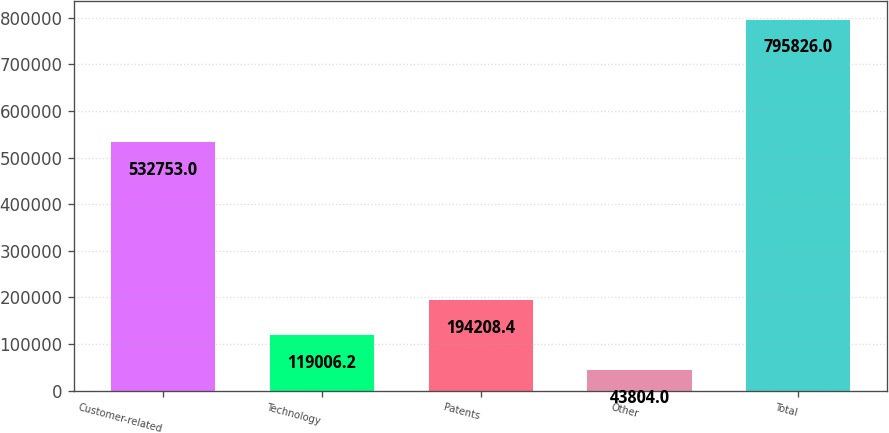<chart> <loc_0><loc_0><loc_500><loc_500><bar_chart><fcel>Customer-related<fcel>Technology<fcel>Patents<fcel>Other<fcel>Total<nl><fcel>532753<fcel>119006<fcel>194208<fcel>43804<fcel>795826<nl></chart> 